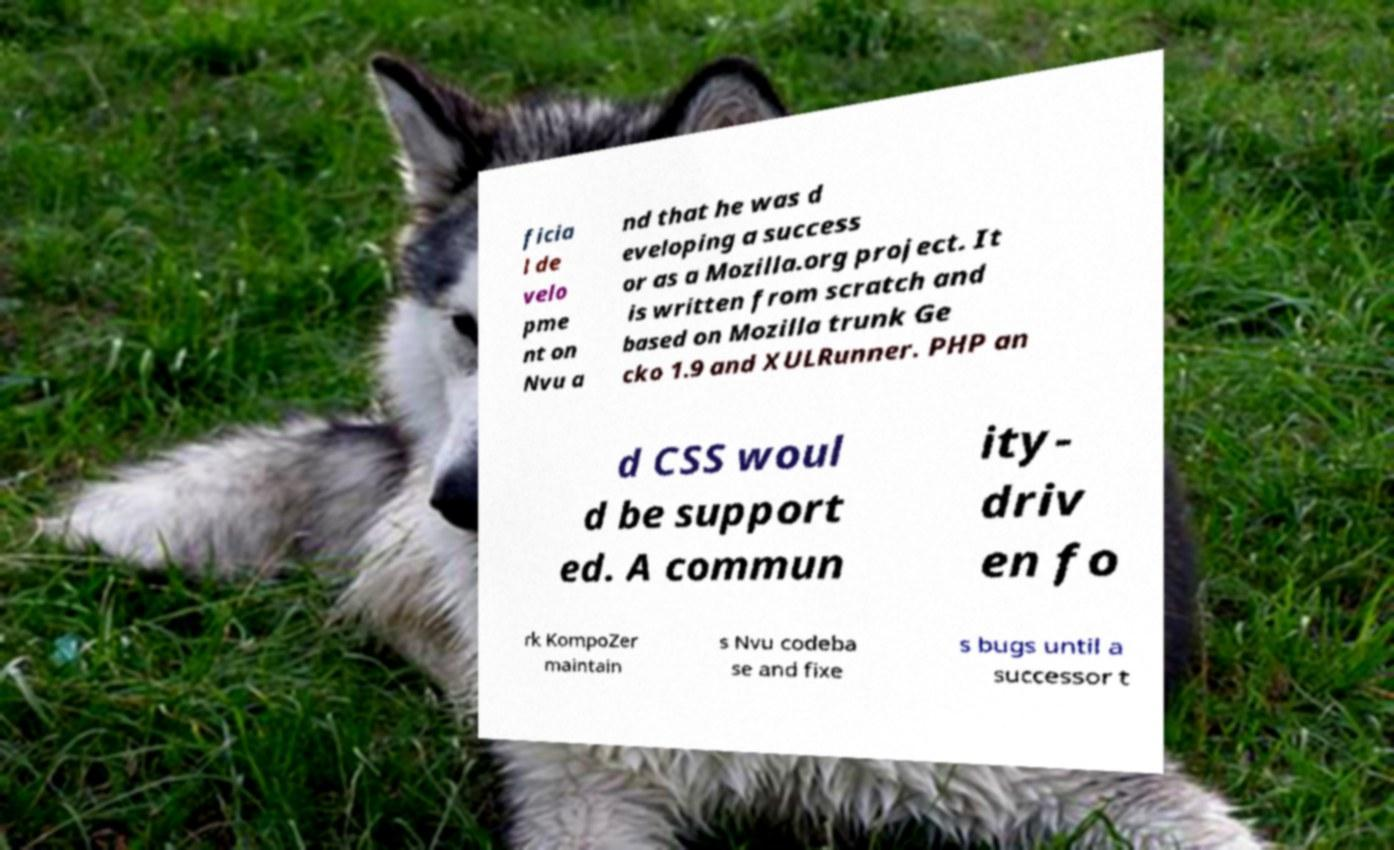Could you assist in decoding the text presented in this image and type it out clearly? ficia l de velo pme nt on Nvu a nd that he was d eveloping a success or as a Mozilla.org project. It is written from scratch and based on Mozilla trunk Ge cko 1.9 and XULRunner. PHP an d CSS woul d be support ed. A commun ity- driv en fo rk KompoZer maintain s Nvu codeba se and fixe s bugs until a successor t 